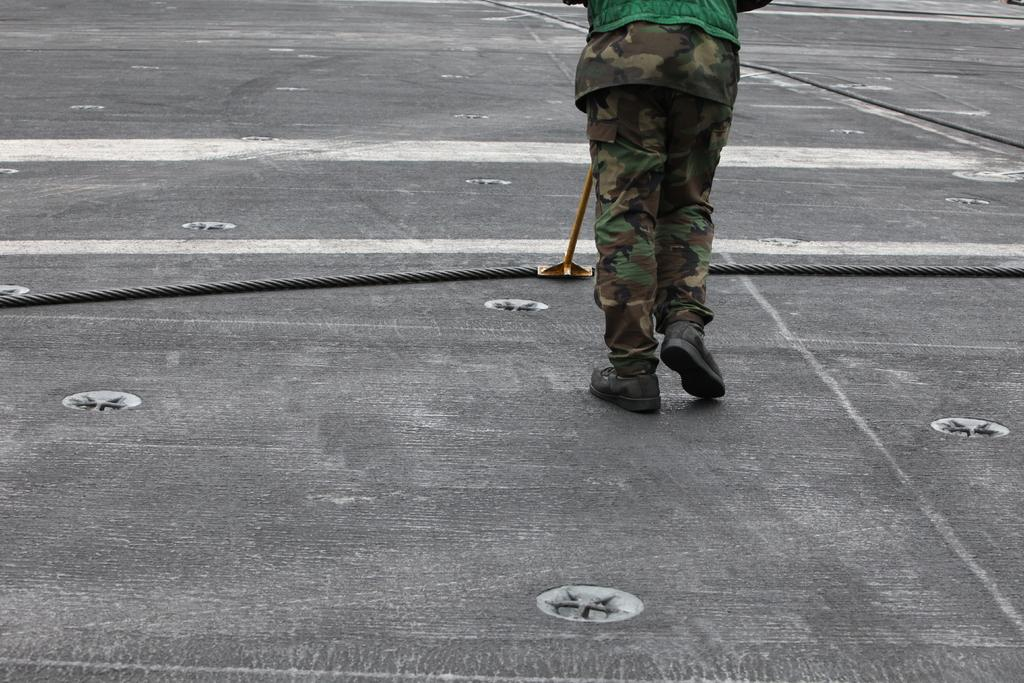What is the main subject of the image? There is a person in the image. What is the person doing in the image? The person is standing on the ground and holding a metal rod. Are there any objects on the ground in the image? Yes, there are ropes on the ground in the image. What type of hobbies does the person have, as indicated by the chickens in the image? There are no chickens present in the image, so it cannot be determined what hobbies the person might have based on this detail. 